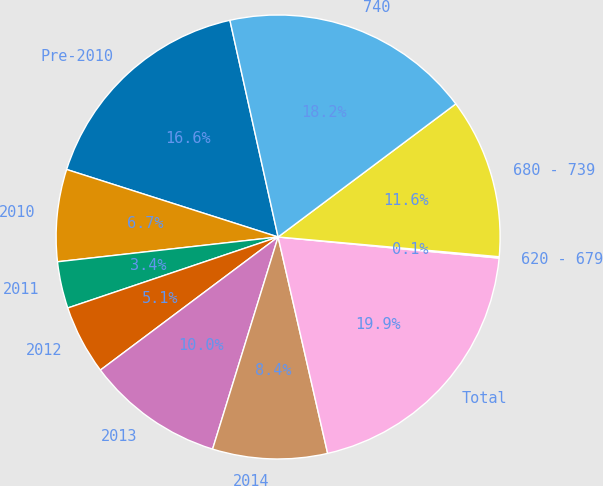Convert chart. <chart><loc_0><loc_0><loc_500><loc_500><pie_chart><fcel>Pre-2010<fcel>2010<fcel>2011<fcel>2012<fcel>2013<fcel>2014<fcel>Total<fcel>620 - 679<fcel>680 - 739<fcel>740<nl><fcel>16.6%<fcel>6.7%<fcel>3.4%<fcel>5.05%<fcel>10.0%<fcel>8.35%<fcel>19.9%<fcel>0.1%<fcel>11.65%<fcel>18.25%<nl></chart> 